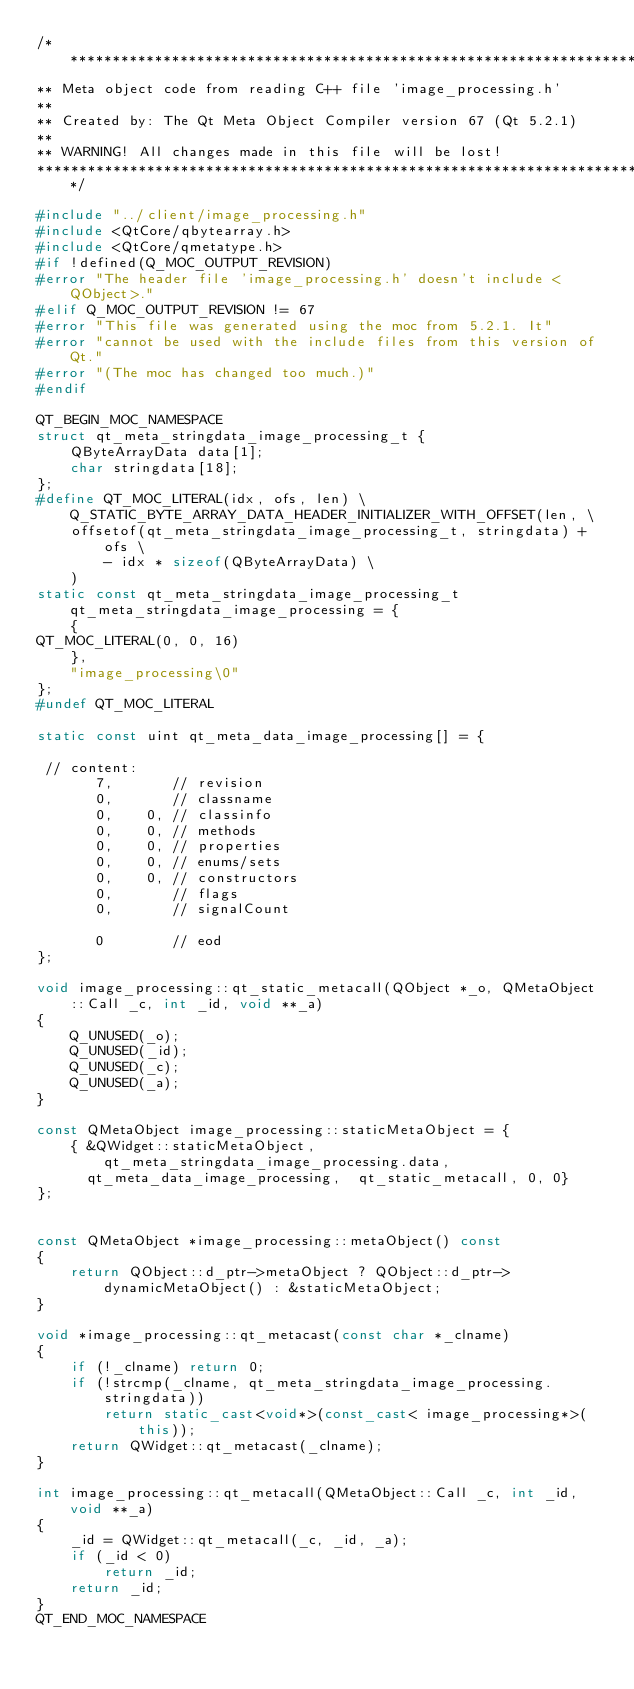<code> <loc_0><loc_0><loc_500><loc_500><_C++_>/****************************************************************************
** Meta object code from reading C++ file 'image_processing.h'
**
** Created by: The Qt Meta Object Compiler version 67 (Qt 5.2.1)
**
** WARNING! All changes made in this file will be lost!
*****************************************************************************/

#include "../client/image_processing.h"
#include <QtCore/qbytearray.h>
#include <QtCore/qmetatype.h>
#if !defined(Q_MOC_OUTPUT_REVISION)
#error "The header file 'image_processing.h' doesn't include <QObject>."
#elif Q_MOC_OUTPUT_REVISION != 67
#error "This file was generated using the moc from 5.2.1. It"
#error "cannot be used with the include files from this version of Qt."
#error "(The moc has changed too much.)"
#endif

QT_BEGIN_MOC_NAMESPACE
struct qt_meta_stringdata_image_processing_t {
    QByteArrayData data[1];
    char stringdata[18];
};
#define QT_MOC_LITERAL(idx, ofs, len) \
    Q_STATIC_BYTE_ARRAY_DATA_HEADER_INITIALIZER_WITH_OFFSET(len, \
    offsetof(qt_meta_stringdata_image_processing_t, stringdata) + ofs \
        - idx * sizeof(QByteArrayData) \
    )
static const qt_meta_stringdata_image_processing_t qt_meta_stringdata_image_processing = {
    {
QT_MOC_LITERAL(0, 0, 16)
    },
    "image_processing\0"
};
#undef QT_MOC_LITERAL

static const uint qt_meta_data_image_processing[] = {

 // content:
       7,       // revision
       0,       // classname
       0,    0, // classinfo
       0,    0, // methods
       0,    0, // properties
       0,    0, // enums/sets
       0,    0, // constructors
       0,       // flags
       0,       // signalCount

       0        // eod
};

void image_processing::qt_static_metacall(QObject *_o, QMetaObject::Call _c, int _id, void **_a)
{
    Q_UNUSED(_o);
    Q_UNUSED(_id);
    Q_UNUSED(_c);
    Q_UNUSED(_a);
}

const QMetaObject image_processing::staticMetaObject = {
    { &QWidget::staticMetaObject, qt_meta_stringdata_image_processing.data,
      qt_meta_data_image_processing,  qt_static_metacall, 0, 0}
};


const QMetaObject *image_processing::metaObject() const
{
    return QObject::d_ptr->metaObject ? QObject::d_ptr->dynamicMetaObject() : &staticMetaObject;
}

void *image_processing::qt_metacast(const char *_clname)
{
    if (!_clname) return 0;
    if (!strcmp(_clname, qt_meta_stringdata_image_processing.stringdata))
        return static_cast<void*>(const_cast< image_processing*>(this));
    return QWidget::qt_metacast(_clname);
}

int image_processing::qt_metacall(QMetaObject::Call _c, int _id, void **_a)
{
    _id = QWidget::qt_metacall(_c, _id, _a);
    if (_id < 0)
        return _id;
    return _id;
}
QT_END_MOC_NAMESPACE
</code> 